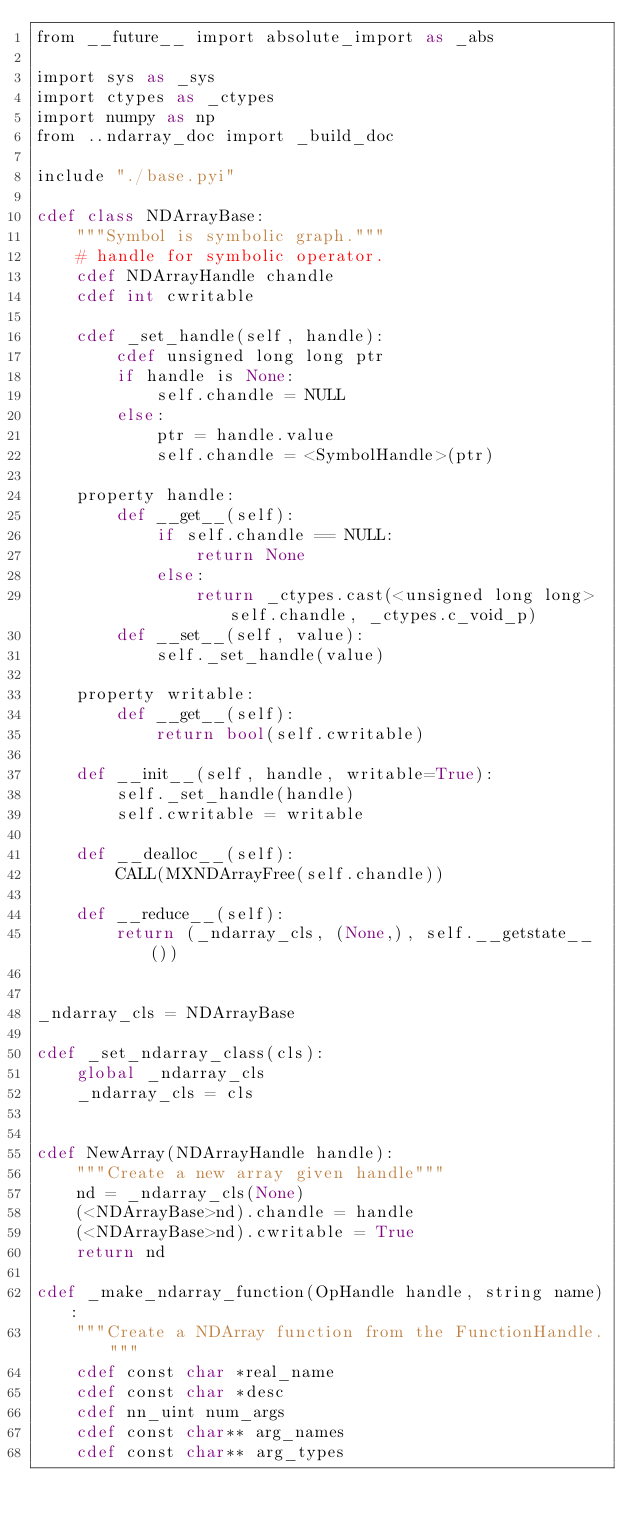Convert code to text. <code><loc_0><loc_0><loc_500><loc_500><_Cython_>from __future__ import absolute_import as _abs

import sys as _sys
import ctypes as _ctypes
import numpy as np
from ..ndarray_doc import _build_doc

include "./base.pyi"

cdef class NDArrayBase:
    """Symbol is symbolic graph."""
    # handle for symbolic operator.
    cdef NDArrayHandle chandle
    cdef int cwritable

    cdef _set_handle(self, handle):
        cdef unsigned long long ptr
        if handle is None:
            self.chandle = NULL
        else:
            ptr = handle.value
            self.chandle = <SymbolHandle>(ptr)

    property handle:
        def __get__(self):
            if self.chandle == NULL:
                return None
            else:
                return _ctypes.cast(<unsigned long long>self.chandle, _ctypes.c_void_p)
        def __set__(self, value):
            self._set_handle(value)

    property writable:
        def __get__(self):
            return bool(self.cwritable)

    def __init__(self, handle, writable=True):
        self._set_handle(handle)
        self.cwritable = writable

    def __dealloc__(self):
        CALL(MXNDArrayFree(self.chandle))

    def __reduce__(self):
        return (_ndarray_cls, (None,), self.__getstate__())


_ndarray_cls = NDArrayBase

cdef _set_ndarray_class(cls):
    global _ndarray_cls
    _ndarray_cls = cls


cdef NewArray(NDArrayHandle handle):
    """Create a new array given handle"""
    nd = _ndarray_cls(None)
    (<NDArrayBase>nd).chandle = handle
    (<NDArrayBase>nd).cwritable = True
    return nd

cdef _make_ndarray_function(OpHandle handle, string name):
    """Create a NDArray function from the FunctionHandle."""
    cdef const char *real_name
    cdef const char *desc
    cdef nn_uint num_args
    cdef const char** arg_names
    cdef const char** arg_types</code> 